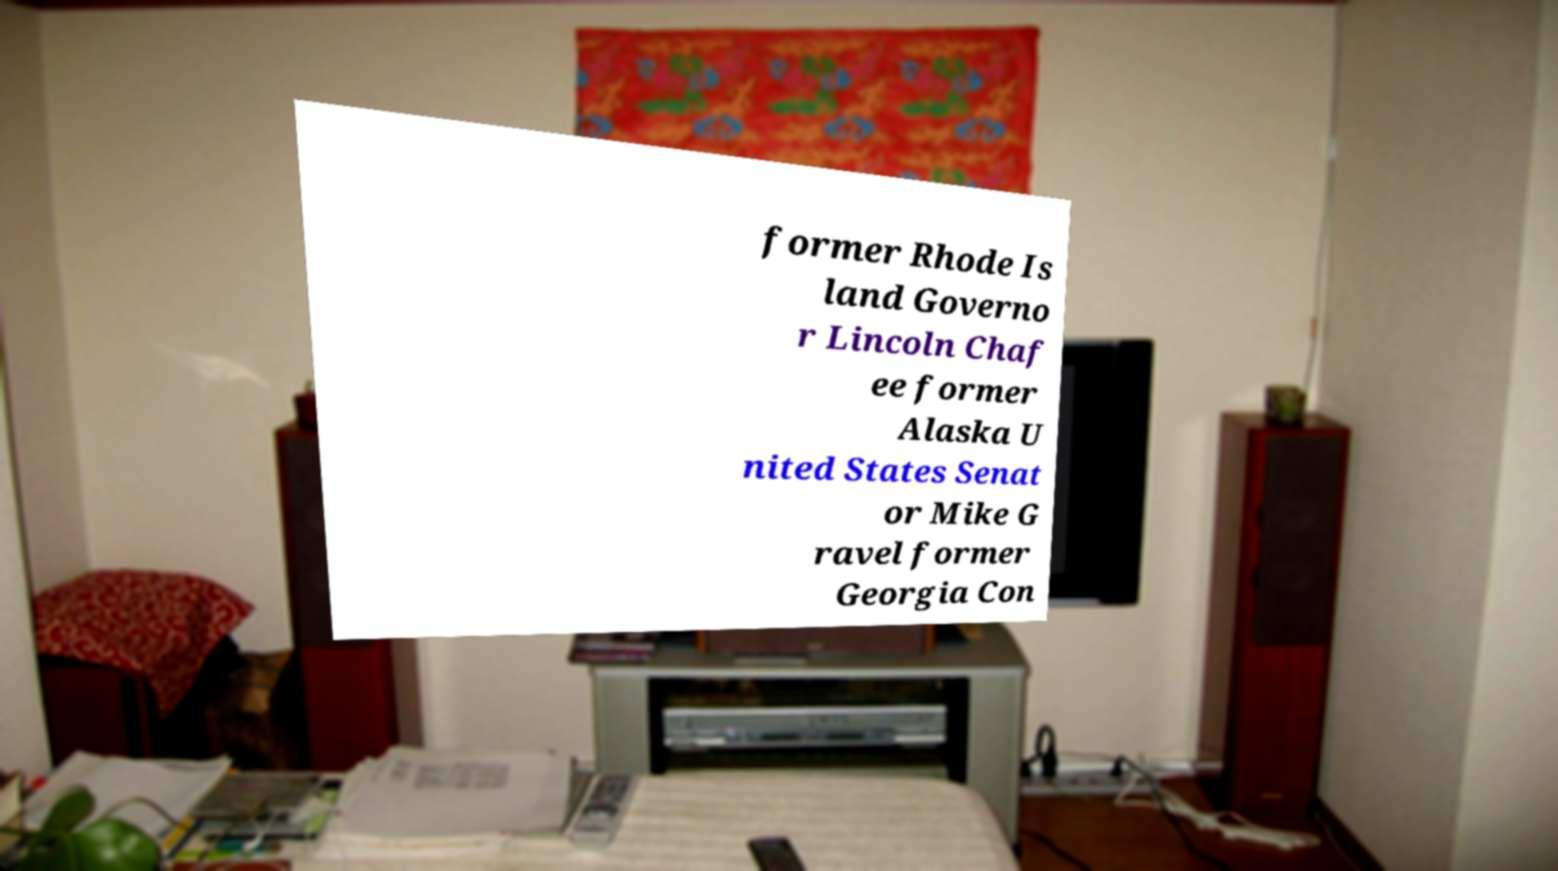What messages or text are displayed in this image? I need them in a readable, typed format. former Rhode Is land Governo r Lincoln Chaf ee former Alaska U nited States Senat or Mike G ravel former Georgia Con 